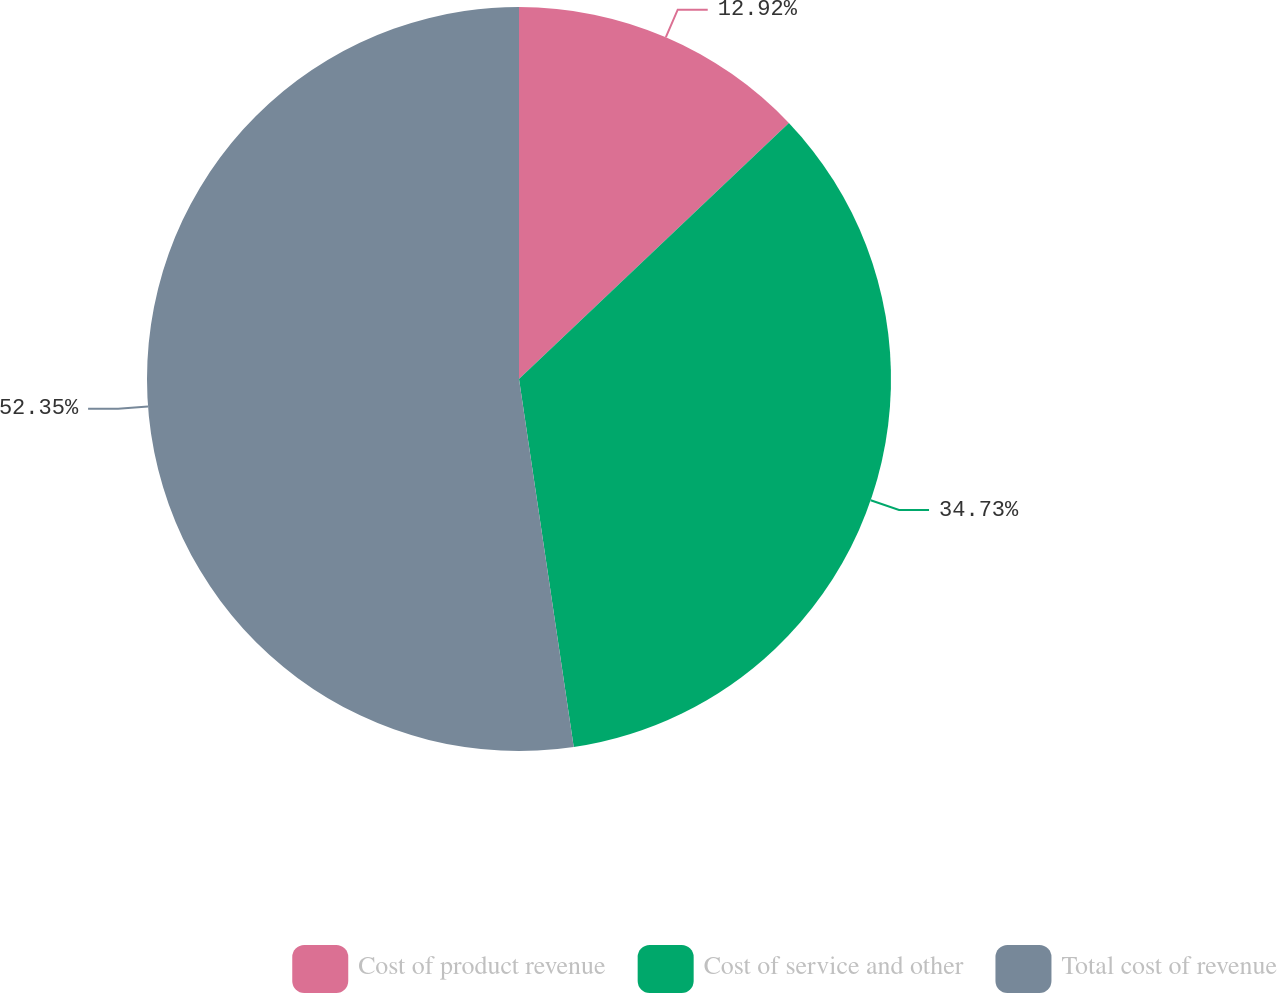<chart> <loc_0><loc_0><loc_500><loc_500><pie_chart><fcel>Cost of product revenue<fcel>Cost of service and other<fcel>Total cost of revenue<nl><fcel>12.92%<fcel>34.73%<fcel>52.35%<nl></chart> 